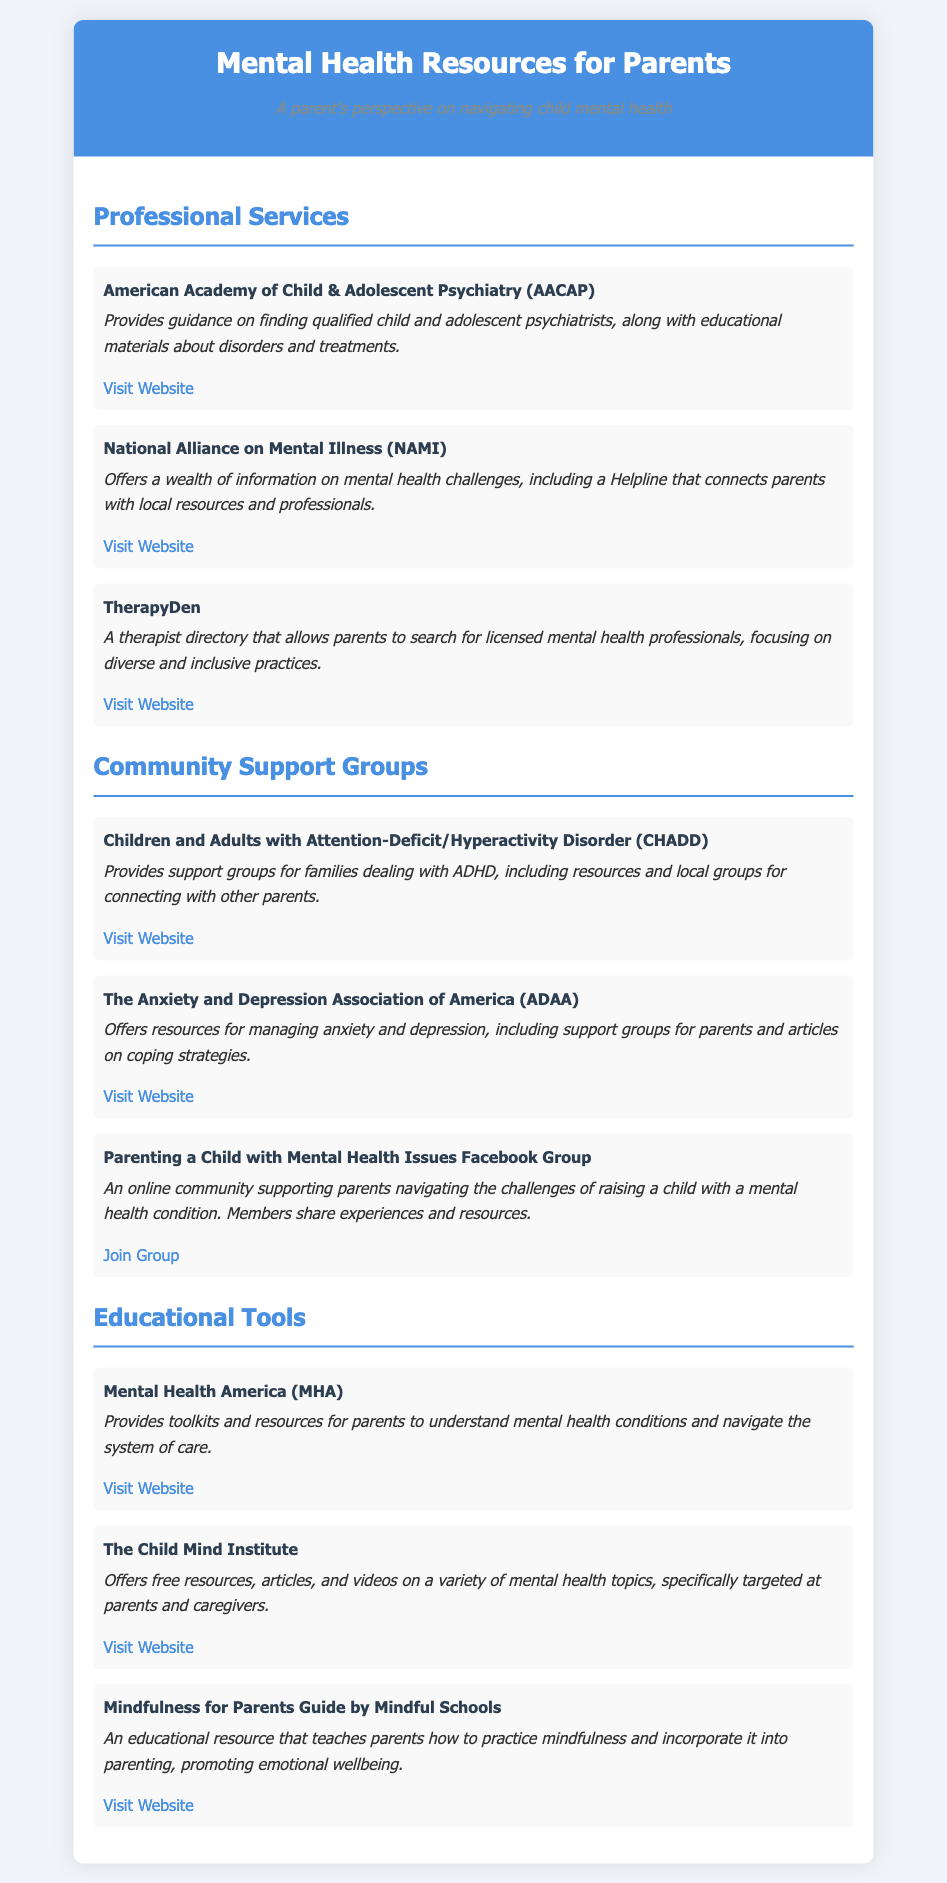What is the title of the document? The title indicates the subject matter of the document, which is centered around mental health resources for parents.
Answer: Mental Health Resources for Parents How many professional services are listed? By counting the services in the Professional Services section, we find there are three.
Answer: 3 What organization provides toolkits for parents? This organization is mentioned in the Educational Tools section, focusing on resources for understanding mental health.
Answer: Mental Health America Which community group focuses on ADHD? Identifying the group in the Community Support Groups section helps to understand the specific focus area.
Answer: CHADD What type of online community is mentioned? The document refers to a specific type of community resource aimed at parents, providing mutual support.
Answer: Facebook Group Name one educational tool that promotes mindfulness. This question requires identifying a resource in the Educational Tools section focused on mindfulness for parents.
Answer: Mindfulness for Parents Guide by Mindful Schools Which organization provides a Helpline for parents? This organization is highlighted in the Professional Services section for its supportive resources.
Answer: National Alliance on Mental Illness How many community support groups are listed? By tallying the groups in the Community Support Groups section, we see that there are three.
Answer: 3 What is a focus area of the Child Mind Institute? Understanding what kind of resources this organization provides from the Educational Tools section.
Answer: Mental health topics 